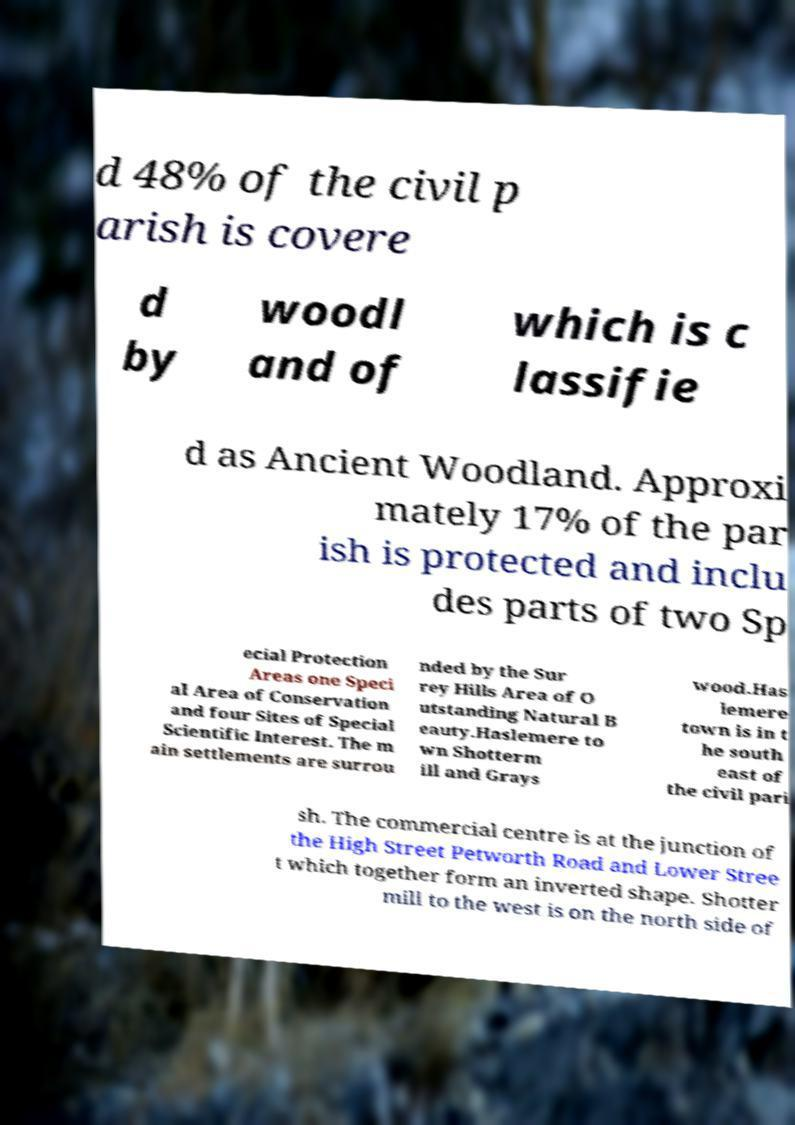Can you read and provide the text displayed in the image?This photo seems to have some interesting text. Can you extract and type it out for me? d 48% of the civil p arish is covere d by woodl and of which is c lassifie d as Ancient Woodland. Approxi mately 17% of the par ish is protected and inclu des parts of two Sp ecial Protection Areas one Speci al Area of Conservation and four Sites of Special Scientific Interest. The m ain settlements are surrou nded by the Sur rey Hills Area of O utstanding Natural B eauty.Haslemere to wn Shotterm ill and Grays wood.Has lemere town is in t he south east of the civil pari sh. The commercial centre is at the junction of the High Street Petworth Road and Lower Stree t which together form an inverted shape. Shotter mill to the west is on the north side of 